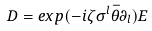<formula> <loc_0><loc_0><loc_500><loc_500>D = e x p ( - i \zeta \sigma ^ { l } \bar { \theta } \partial _ { l } ) E</formula> 